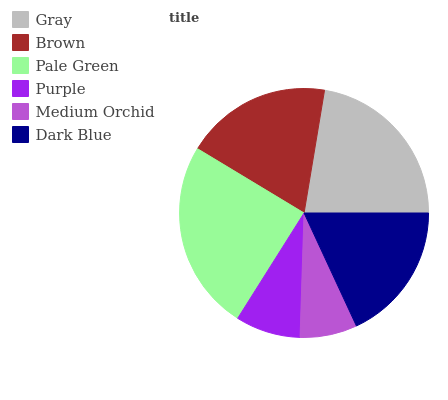Is Medium Orchid the minimum?
Answer yes or no. Yes. Is Pale Green the maximum?
Answer yes or no. Yes. Is Brown the minimum?
Answer yes or no. No. Is Brown the maximum?
Answer yes or no. No. Is Gray greater than Brown?
Answer yes or no. Yes. Is Brown less than Gray?
Answer yes or no. Yes. Is Brown greater than Gray?
Answer yes or no. No. Is Gray less than Brown?
Answer yes or no. No. Is Brown the high median?
Answer yes or no. Yes. Is Dark Blue the low median?
Answer yes or no. Yes. Is Dark Blue the high median?
Answer yes or no. No. Is Brown the low median?
Answer yes or no. No. 